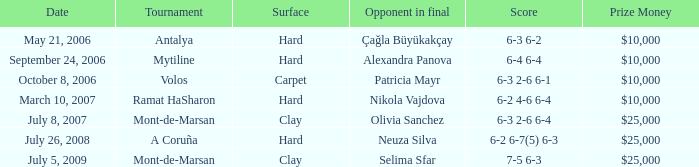What is the surface for the Volos tournament? Carpet. 